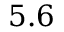<formula> <loc_0><loc_0><loc_500><loc_500>5 . 6</formula> 